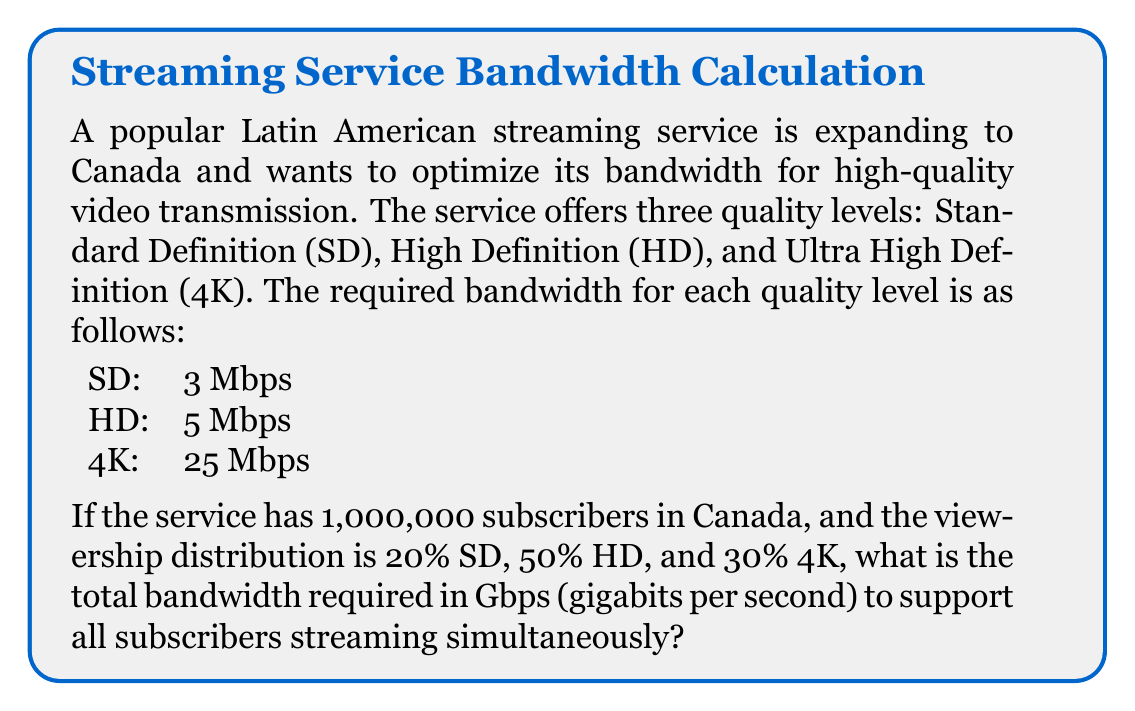Teach me how to tackle this problem. Let's break this down step-by-step:

1. Calculate the number of subscribers for each quality level:
   SD: $1,000,000 \times 0.20 = 200,000$
   HD: $1,000,000 \times 0.50 = 500,000$
   4K: $1,000,000 \times 0.30 = 300,000$

2. Calculate the total bandwidth required for each quality level:
   SD: $200,000 \times 3 \text{ Mbps} = 600,000 \text{ Mbps}$
   HD: $500,000 \times 5 \text{ Mbps} = 2,500,000 \text{ Mbps}$
   4K: $300,000 \times 25 \text{ Mbps} = 7,500,000 \text{ Mbps}$

3. Sum up the total bandwidth:
   $\text{Total} = 600,000 + 2,500,000 + 7,500,000 = 10,600,000 \text{ Mbps}$

4. Convert Mbps to Gbps:
   $$10,600,000 \text{ Mbps} \times \frac{1 \text{ Gbps}}{1000 \text{ Mbps}} = 10,600 \text{ Gbps}$$

Therefore, the total bandwidth required is 10,600 Gbps.
Answer: 10,600 Gbps 